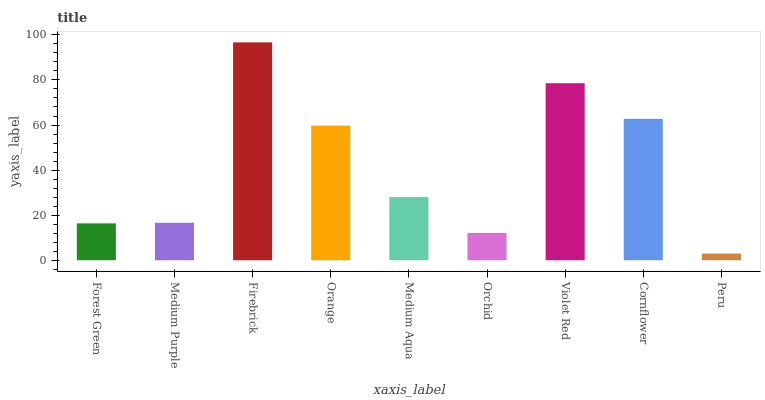Is Peru the minimum?
Answer yes or no. Yes. Is Firebrick the maximum?
Answer yes or no. Yes. Is Medium Purple the minimum?
Answer yes or no. No. Is Medium Purple the maximum?
Answer yes or no. No. Is Medium Purple greater than Forest Green?
Answer yes or no. Yes. Is Forest Green less than Medium Purple?
Answer yes or no. Yes. Is Forest Green greater than Medium Purple?
Answer yes or no. No. Is Medium Purple less than Forest Green?
Answer yes or no. No. Is Medium Aqua the high median?
Answer yes or no. Yes. Is Medium Aqua the low median?
Answer yes or no. Yes. Is Forest Green the high median?
Answer yes or no. No. Is Violet Red the low median?
Answer yes or no. No. 